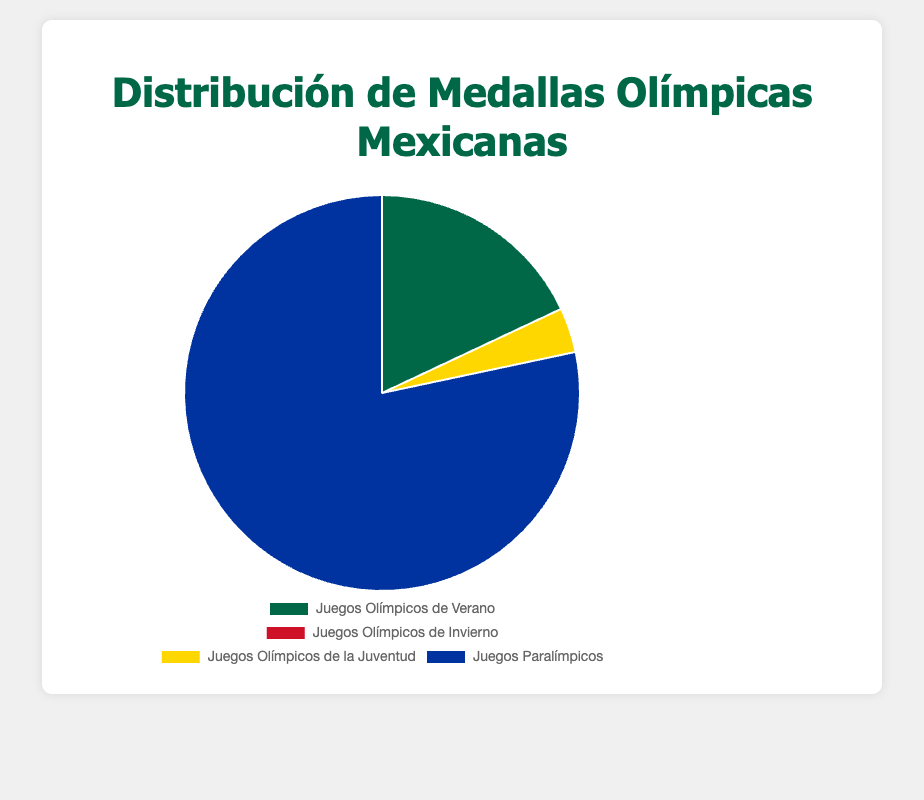What percentage of total medals were won in the Summer Olympics? To find the percentage, sum the total number of medals (69 Summer, 0 Winter, 14 Youth, 300 Paralympics). The total is 383. Then, calculate the percentage of Summer Olympic medals: (69 / 383) * 100%.
Answer: 18% Which event has the highest number of medals won by Mexican athletes? Compare the total number of medals for each category: Summer Olympics (69), Winter Olympics (0), Youth Olympics (14), Paralympics (300). The highest number is in the Paralympics category.
Answer: Paralympics How many more medals were won in the Paralympics compared to the Summer Olympics? Subtract the number of Summer Olympics medals from the Paralympics medals: 300 - 69.
Answer: 231 What is the ratio of medals won in the Youth Olympics to those won in the Summer Olympics? Divide the number of Youth Olympics medals by the number of Summer Olympics medals: 14 / 69.
Answer: 0.20 Which segment of the pie chart is represented using a green color? Identify the segment colors from the chart, where the Summer Olympics segment is colored green.
Answer: Summer Olympics Are there any medals won by Mexican athletes in the Winter Olympics? Check the data for the Winter Olympics and note that the number of medals is zero.
Answer: No What is the total number of medals won by Mexican athletes across all specified Olympic events? Sum the medals in all categories: 69 (Summer) + 0 (Winter) + 14 (Youth) + 300 (Paralympics).
Answer: 383 Which category has the smallest number of medals, and what is that number? Compare the total number of medals in each category: Summer Olympics (69), Winter Olympics (0), Youth Olympics (14), Paralympics (300). The smallest number is 0 in the Winter Olympics.
Answer: Winter Olympics, 0 How many times more medals were won in the Youth Olympics than in the Winter Olympics? Since the Winter Olympics has 0 medals and Youth Olympics have 14, you can't calculate a ratio based on 0. However, mathematically, any number of medals that is non-zero is an infinite times more than zero.
Answer: Infinite 